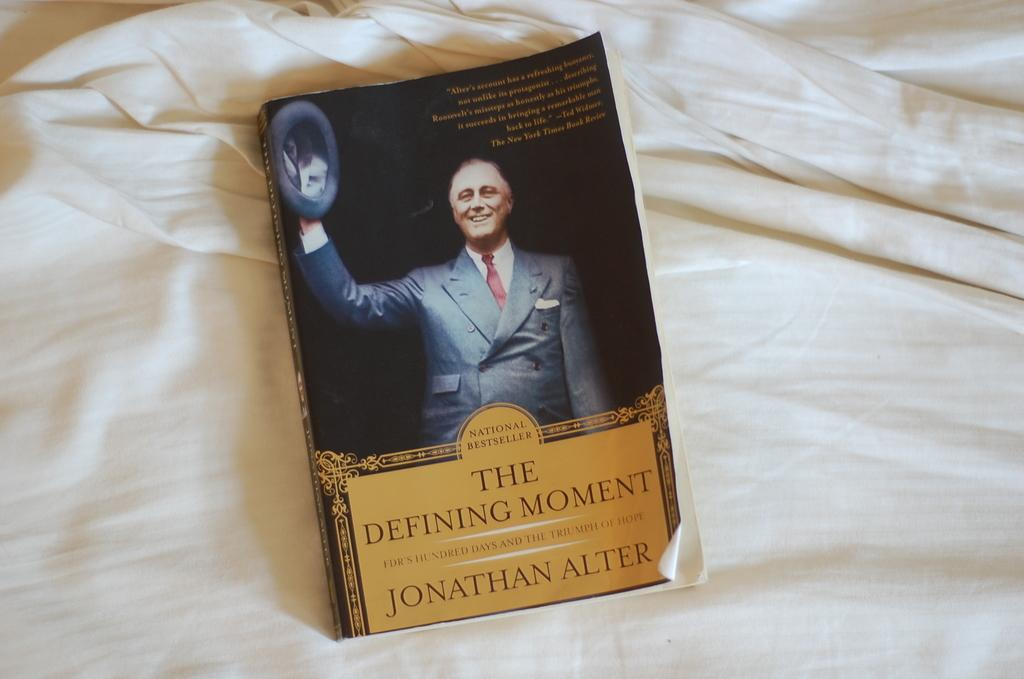<image>
Relay a brief, clear account of the picture shown. A book titled The Defining Moment sits on a bedsheet. 